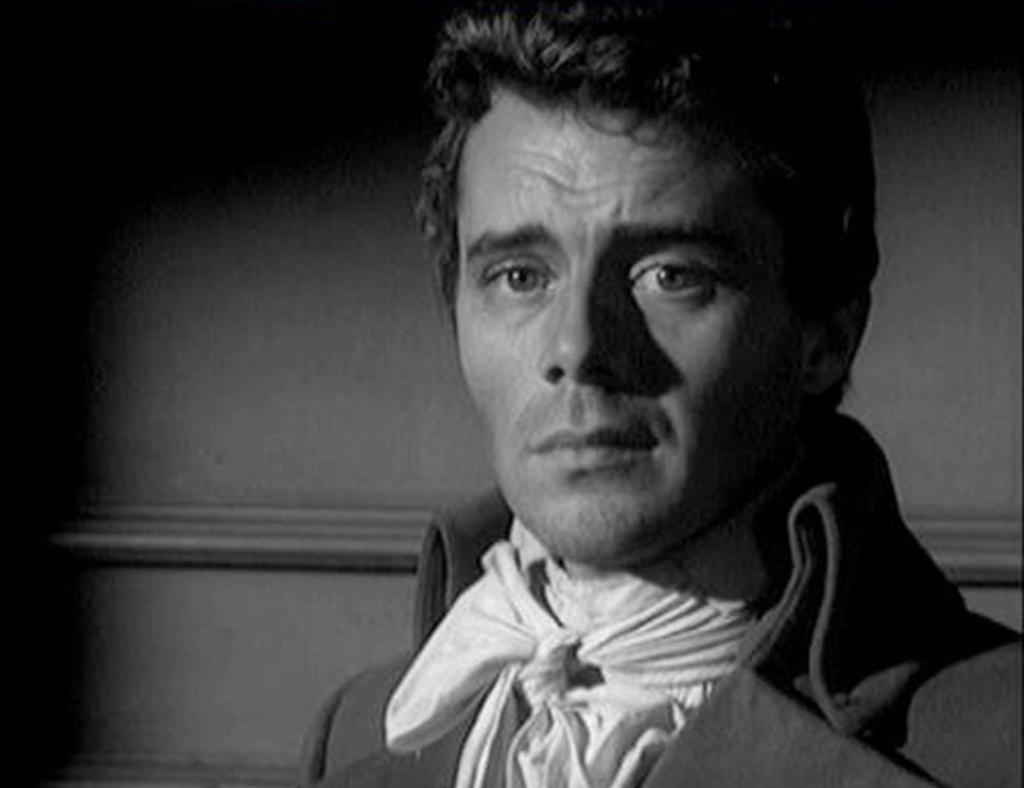Who is the main subject in the image? There is a man in the middle of the image. What can be seen in the background of the image? There is a wall in the background of the image. What is the color scheme of the image? The image is black and white. What type of amusement ride is present in the image? There is no amusement ride present in the image; it features a man and a wall in a black and white setting. How does the cart move in the image? There is no cart present in the image. 